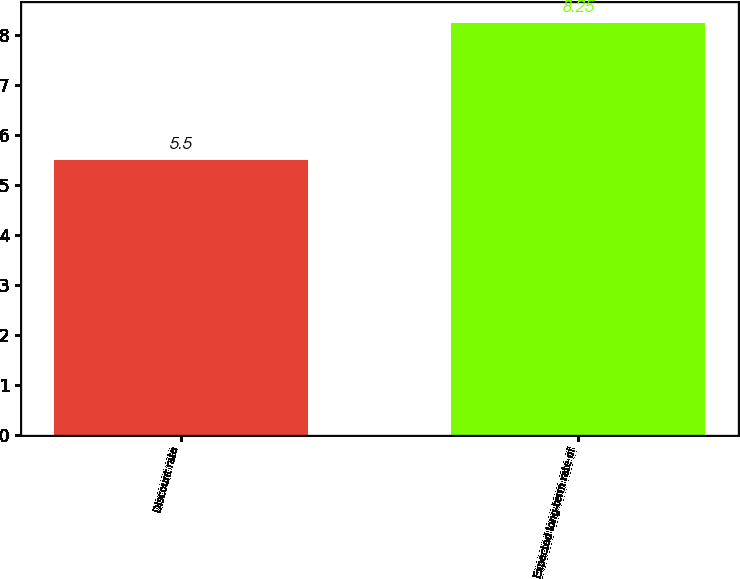Convert chart to OTSL. <chart><loc_0><loc_0><loc_500><loc_500><bar_chart><fcel>Discount rate<fcel>Expected long-term rate of<nl><fcel>5.5<fcel>8.25<nl></chart> 